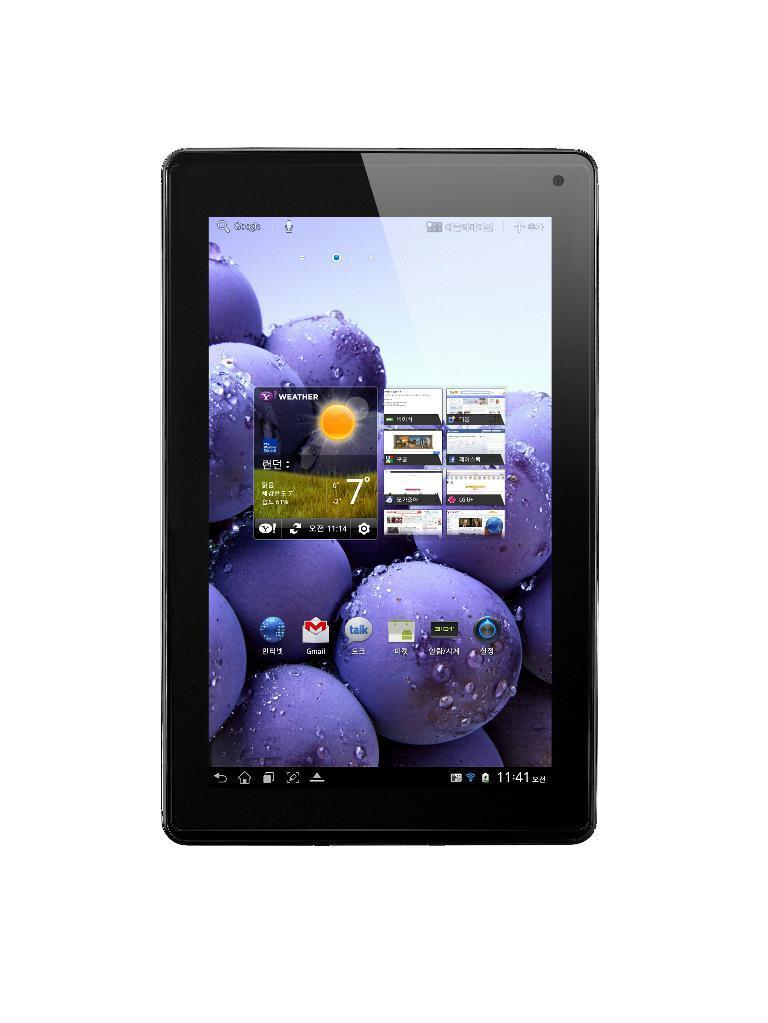In one or two sentences, can you explain what this image depicts? In this image there is a tab. In that there is a text with images. 